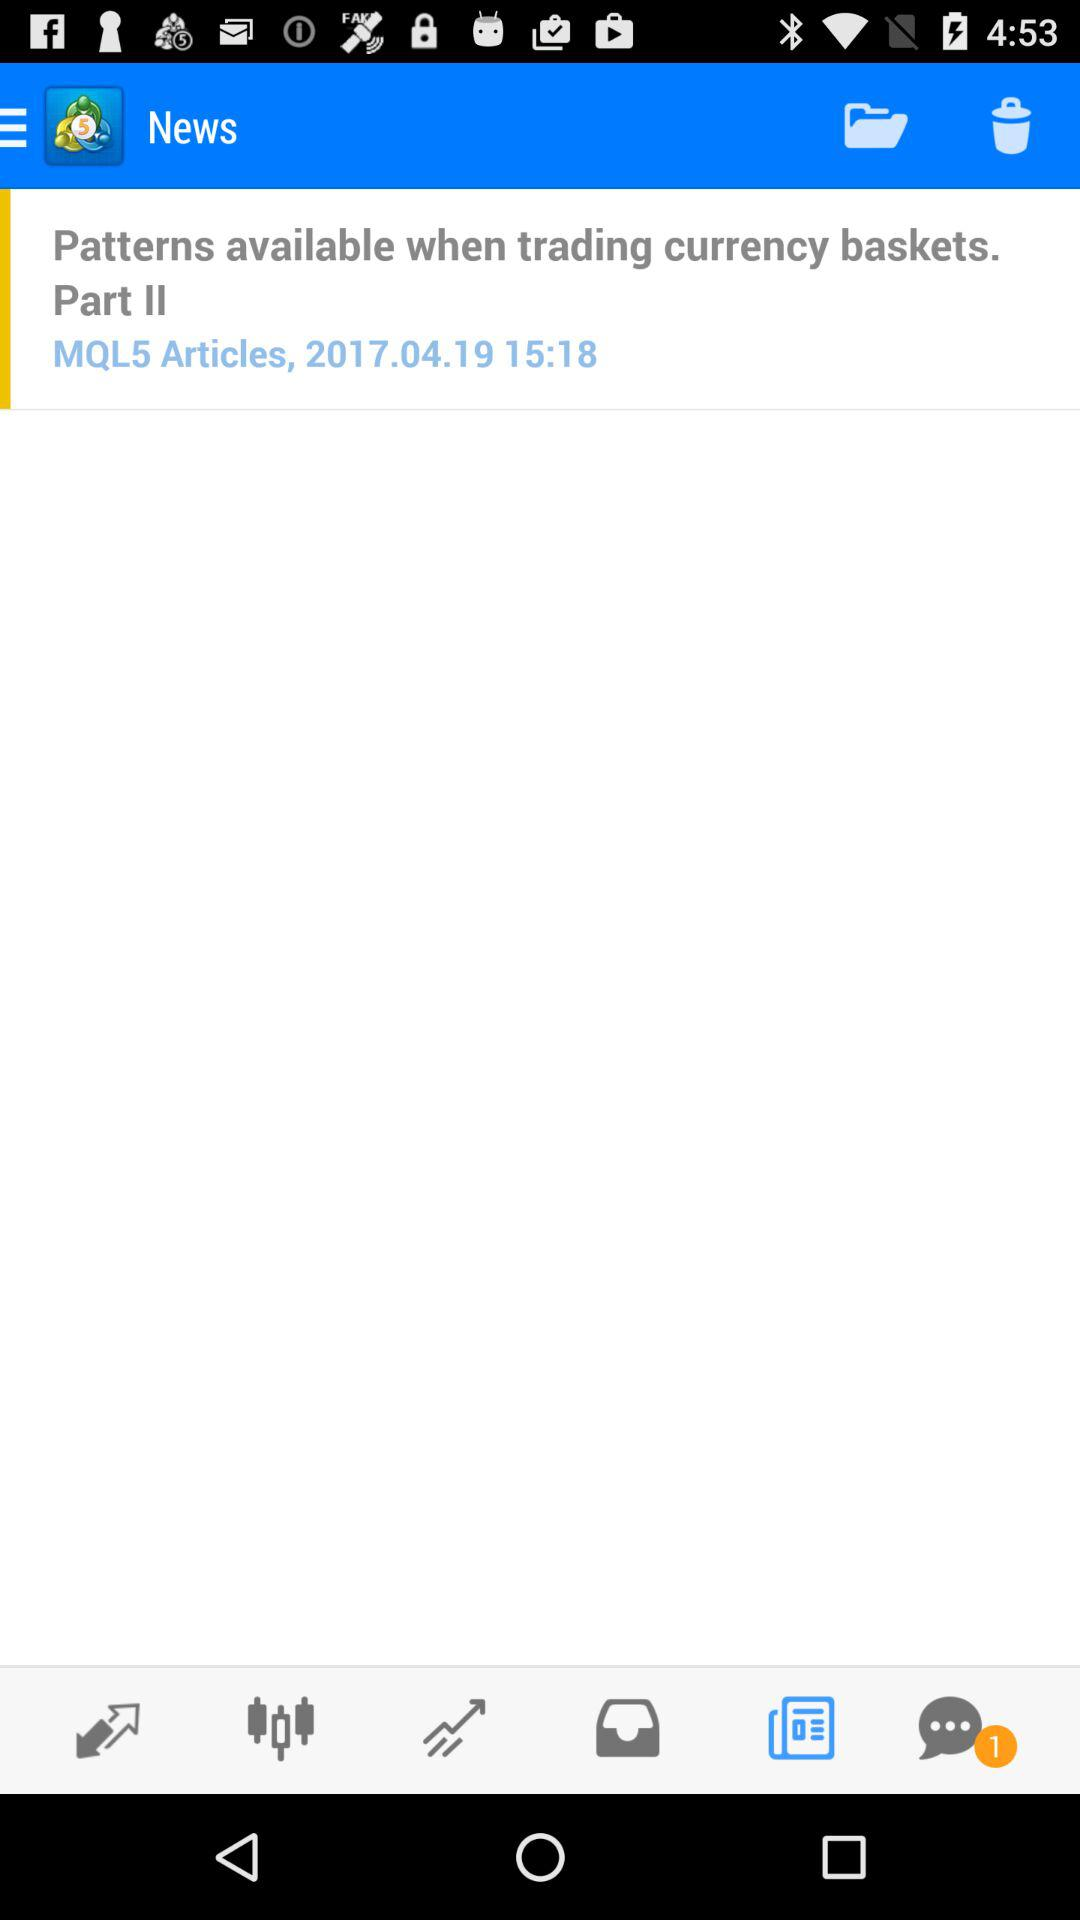What is the number of unread chats? The number of unread chats is 1. 